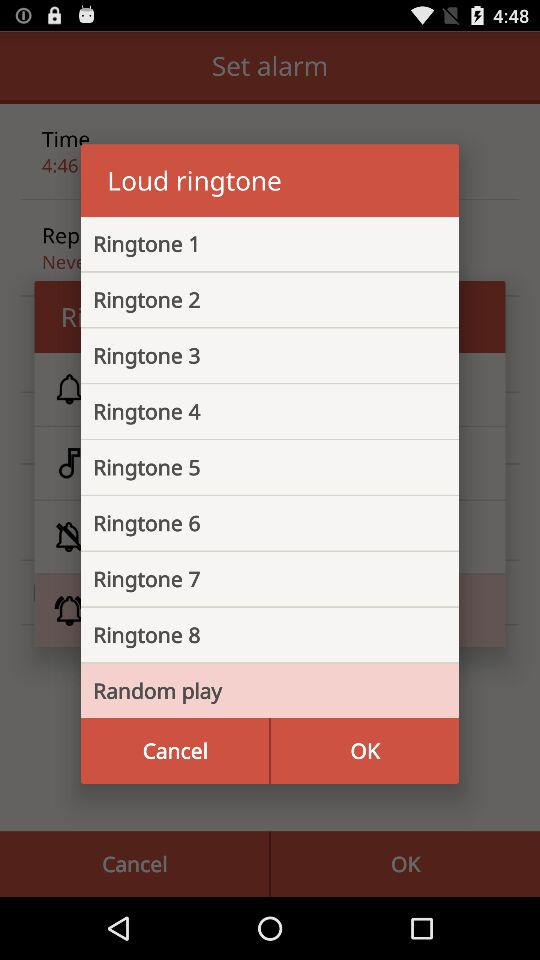Which option is selected? The selected option is "Random play". 